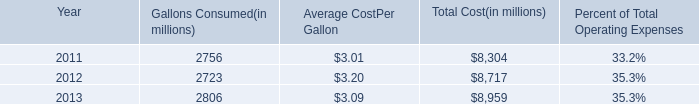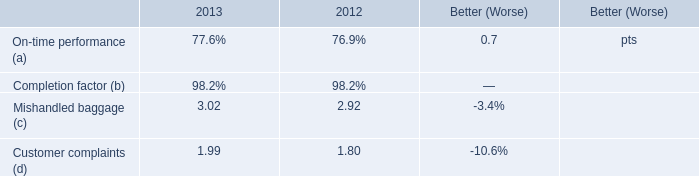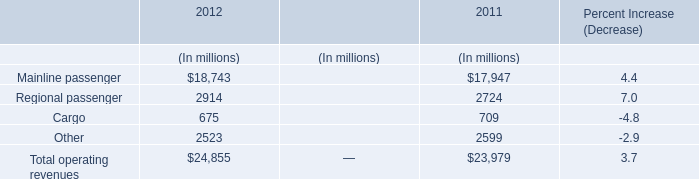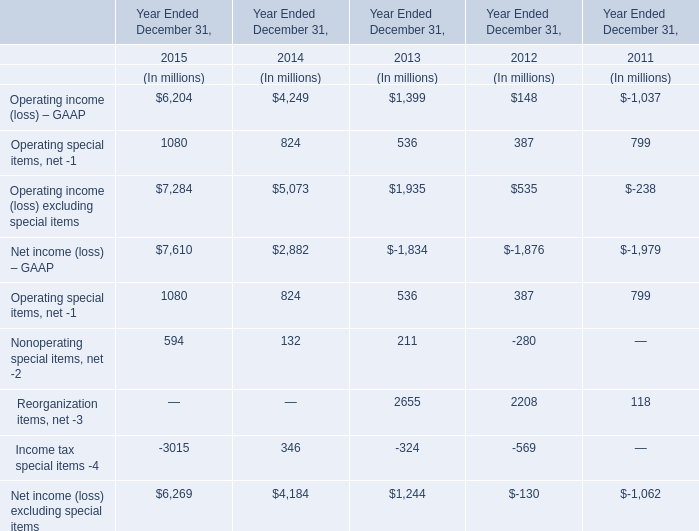what is the percentage effect of the hedges on the anticipated increase in the 2014 increase in fuel expenses 
Computations: ((104 - 87) / 87)
Answer: 0.1954. 